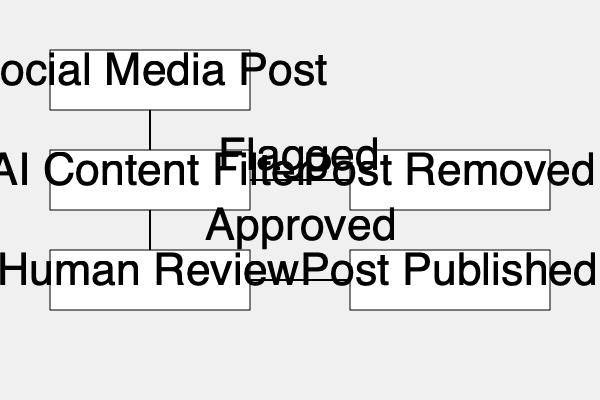In the given flowchart of AI-assisted social media content moderation, which step could potentially lead to biased censorship if the AI model is not properly designed and trained? To identify the potential misuse of AI in this content moderation flowchart, we need to analyze each step:

1. Social Media Post: This is the input stage and doesn't involve AI decision-making.

2. AI Content Filter: This is the critical step where AI is used to analyze and flag content. If not properly designed and trained, the AI model could introduce bias in the following ways:
   a) Dataset bias: If the training data is not diverse or representative, it may lead to unfair treatment of certain groups or topics.
   b) Algorithm bias: The AI model's architecture or learning process might inadvertently favor or disfavor certain types of content.
   c) Contextual misunderstanding: AI might struggle with nuanced content, satire, or culturally specific expressions, leading to over-censorship.

3. Human Review: While this step involves human decision-making, it comes after the AI filter and may not catch all instances of AI bias.

4. Post Removed/Published: These are outcome stages based on previous decisions.

The AI Content Filter stage is the most critical point where bias could be introduced systematically. If the AI model is biased, it could disproportionately flag content from certain groups or on specific topics, leading to over-censorship or under-representation of particular viewpoints.
Answer: AI Content Filter 